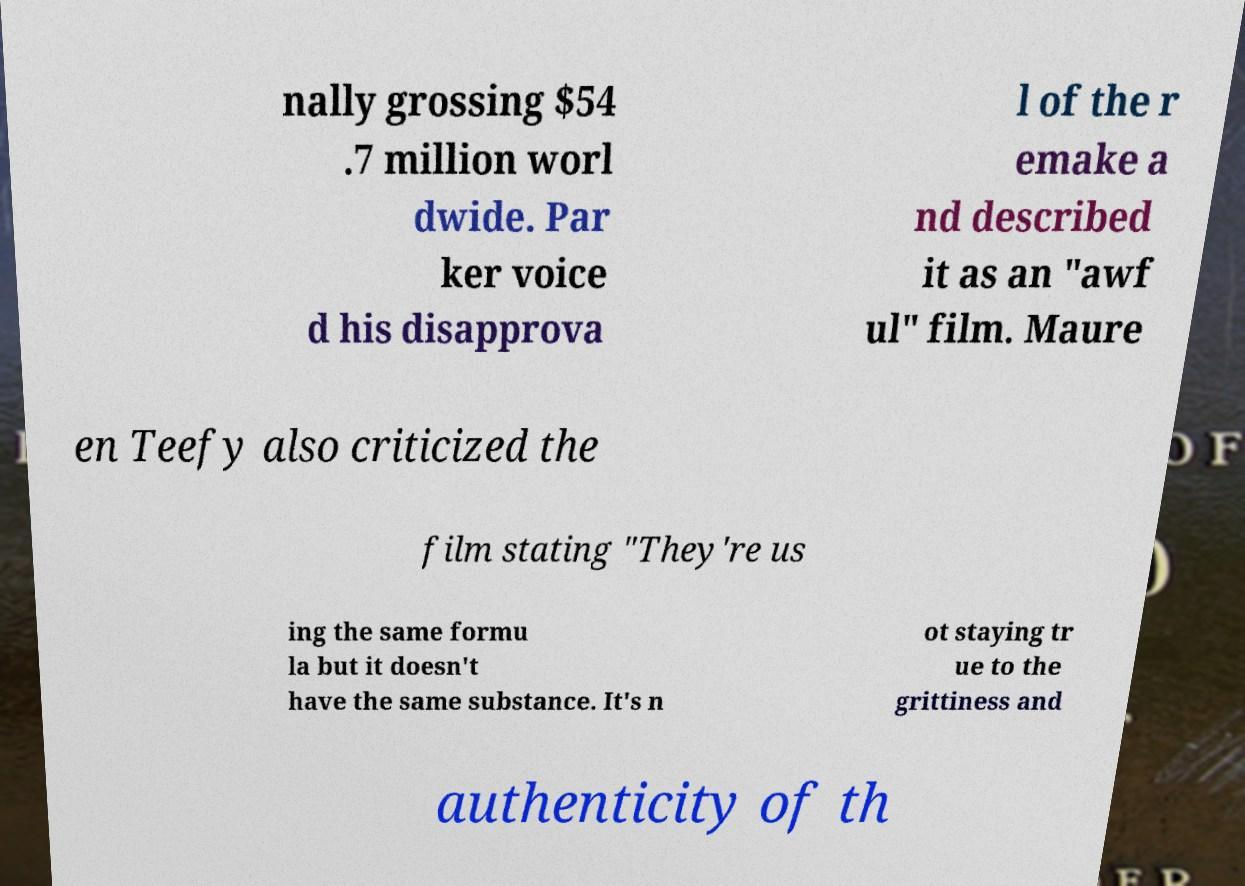Please read and relay the text visible in this image. What does it say? nally grossing $54 .7 million worl dwide. Par ker voice d his disapprova l of the r emake a nd described it as an "awf ul" film. Maure en Teefy also criticized the film stating "They're us ing the same formu la but it doesn't have the same substance. It's n ot staying tr ue to the grittiness and authenticity of th 